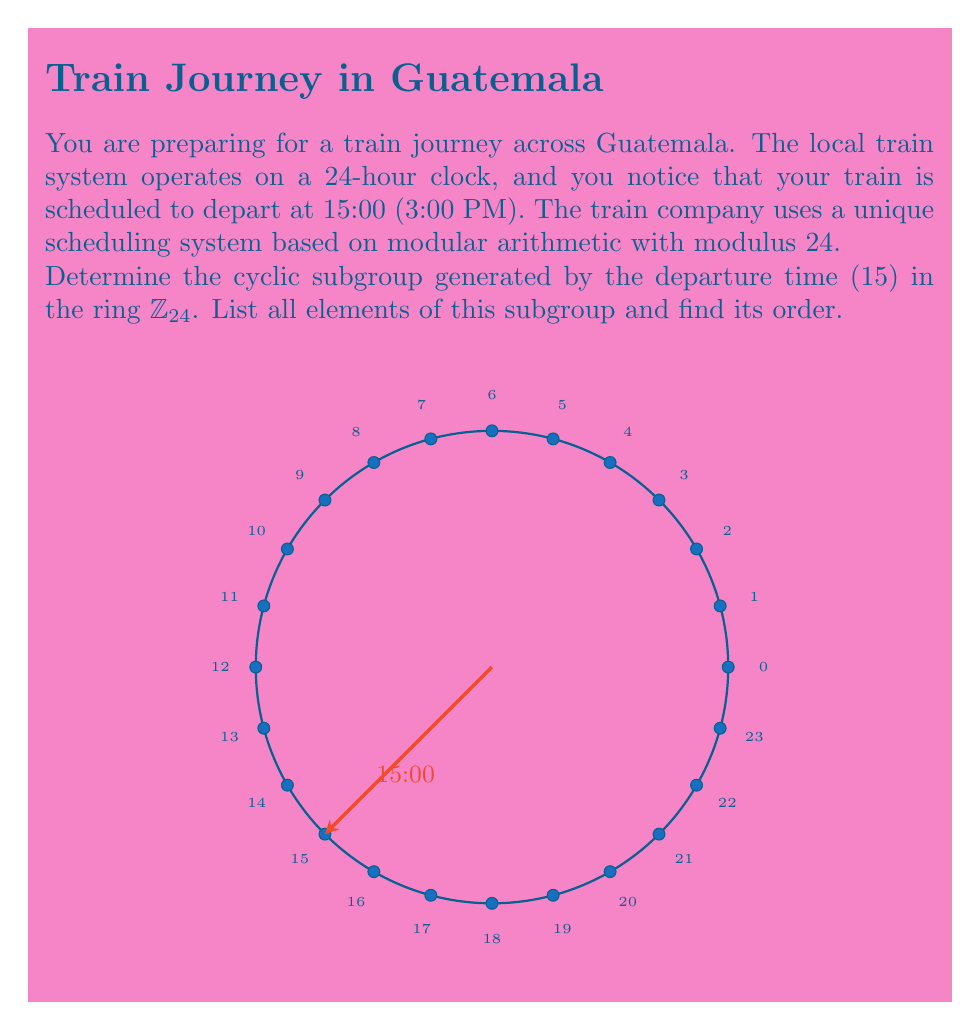Teach me how to tackle this problem. Let's approach this step-by-step:

1) In $\mathbb{Z}_{24}$, we start with the element 15 and repeatedly add it to itself, taking the result modulo 24 each time.

2) Let's calculate the first few elements:
   
   $15 \cdot 1 \equiv 15 \pmod{24}$
   $15 \cdot 2 \equiv 30 \equiv 6 \pmod{24}$
   $15 \cdot 3 \equiv 45 \equiv 21 \pmod{24}$
   $15 \cdot 4 \equiv 60 \equiv 12 \pmod{24}$
   $15 \cdot 5 \equiv 75 \equiv 3 \pmod{24}$
   $15 \cdot 6 \equiv 90 \equiv 18 \pmod{24}$
   $15 \cdot 7 \equiv 105 \equiv 9 \pmod{24}$
   $15 \cdot 8 \equiv 120 \equiv 0 \pmod{24}$

3) We see that $15 \cdot 8 \equiv 0 \pmod{24}$, which means we've returned to the identity element.

4) Therefore, the cyclic subgroup generated by 15 is:
   $\{0, 3, 6, 9, 12, 15, 18, 21\}$

5) The order of this subgroup is 8, as there are 8 distinct elements before we cycle back to 0.

6) We can verify that 15 and 24 are coprime (their greatest common divisor is 1), which explains why the order of the subgroup is 24 ÷ 3 = 8.

This subgroup represents all possible departure times that can be reached by repeatedly adding 3 hours (or 15:00) to the initial departure time.
Answer: $\{0, 3, 6, 9, 12, 15, 18, 21\}$; order 8 